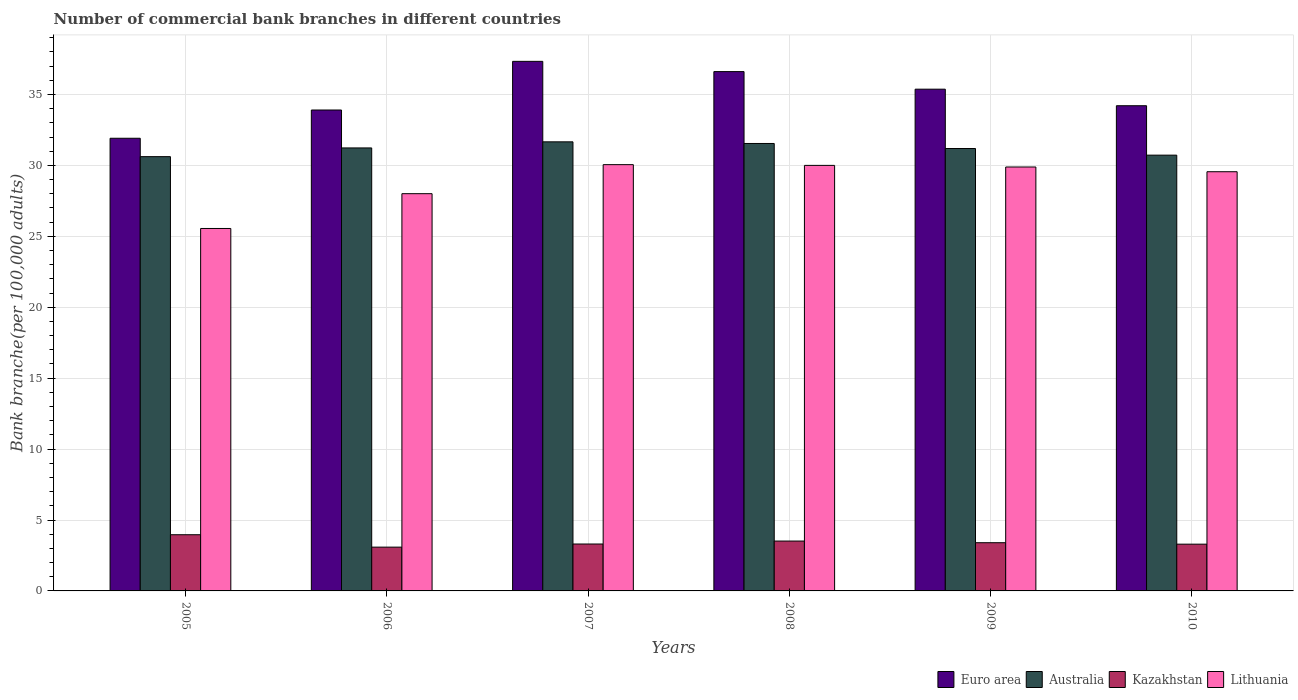How many bars are there on the 6th tick from the left?
Your answer should be very brief. 4. How many bars are there on the 4th tick from the right?
Your answer should be compact. 4. What is the number of commercial bank branches in Kazakhstan in 2008?
Provide a succinct answer. 3.52. Across all years, what is the maximum number of commercial bank branches in Euro area?
Give a very brief answer. 37.34. Across all years, what is the minimum number of commercial bank branches in Australia?
Your answer should be very brief. 30.62. What is the total number of commercial bank branches in Kazakhstan in the graph?
Ensure brevity in your answer.  20.57. What is the difference between the number of commercial bank branches in Australia in 2006 and that in 2008?
Keep it short and to the point. -0.31. What is the difference between the number of commercial bank branches in Lithuania in 2010 and the number of commercial bank branches in Kazakhstan in 2009?
Your answer should be compact. 26.16. What is the average number of commercial bank branches in Lithuania per year?
Offer a very short reply. 28.84. In the year 2008, what is the difference between the number of commercial bank branches in Australia and number of commercial bank branches in Kazakhstan?
Your answer should be very brief. 28.03. What is the ratio of the number of commercial bank branches in Australia in 2005 to that in 2009?
Your response must be concise. 0.98. Is the number of commercial bank branches in Euro area in 2008 less than that in 2010?
Your answer should be compact. No. Is the difference between the number of commercial bank branches in Australia in 2008 and 2009 greater than the difference between the number of commercial bank branches in Kazakhstan in 2008 and 2009?
Your answer should be compact. Yes. What is the difference between the highest and the second highest number of commercial bank branches in Euro area?
Offer a terse response. 0.72. What is the difference between the highest and the lowest number of commercial bank branches in Australia?
Your answer should be very brief. 1.04. In how many years, is the number of commercial bank branches in Australia greater than the average number of commercial bank branches in Australia taken over all years?
Provide a succinct answer. 4. What does the 4th bar from the left in 2009 represents?
Keep it short and to the point. Lithuania. What does the 2nd bar from the right in 2006 represents?
Provide a succinct answer. Kazakhstan. Is it the case that in every year, the sum of the number of commercial bank branches in Kazakhstan and number of commercial bank branches in Euro area is greater than the number of commercial bank branches in Australia?
Your answer should be compact. Yes. How many bars are there?
Your answer should be compact. 24. Are all the bars in the graph horizontal?
Give a very brief answer. No. How many years are there in the graph?
Make the answer very short. 6. Does the graph contain any zero values?
Offer a very short reply. No. Where does the legend appear in the graph?
Your answer should be compact. Bottom right. How many legend labels are there?
Make the answer very short. 4. How are the legend labels stacked?
Offer a terse response. Horizontal. What is the title of the graph?
Your answer should be compact. Number of commercial bank branches in different countries. Does "East Asia (developing only)" appear as one of the legend labels in the graph?
Your answer should be compact. No. What is the label or title of the X-axis?
Your response must be concise. Years. What is the label or title of the Y-axis?
Keep it short and to the point. Bank branche(per 100,0 adults). What is the Bank branche(per 100,000 adults) in Euro area in 2005?
Provide a succinct answer. 31.92. What is the Bank branche(per 100,000 adults) of Australia in 2005?
Provide a succinct answer. 30.62. What is the Bank branche(per 100,000 adults) in Kazakhstan in 2005?
Make the answer very short. 3.96. What is the Bank branche(per 100,000 adults) in Lithuania in 2005?
Your answer should be very brief. 25.55. What is the Bank branche(per 100,000 adults) of Euro area in 2006?
Offer a very short reply. 33.91. What is the Bank branche(per 100,000 adults) in Australia in 2006?
Keep it short and to the point. 31.23. What is the Bank branche(per 100,000 adults) in Kazakhstan in 2006?
Your answer should be compact. 3.09. What is the Bank branche(per 100,000 adults) of Lithuania in 2006?
Your response must be concise. 28.01. What is the Bank branche(per 100,000 adults) in Euro area in 2007?
Offer a very short reply. 37.34. What is the Bank branche(per 100,000 adults) of Australia in 2007?
Ensure brevity in your answer.  31.66. What is the Bank branche(per 100,000 adults) in Kazakhstan in 2007?
Keep it short and to the point. 3.31. What is the Bank branche(per 100,000 adults) in Lithuania in 2007?
Provide a succinct answer. 30.05. What is the Bank branche(per 100,000 adults) of Euro area in 2008?
Make the answer very short. 36.62. What is the Bank branche(per 100,000 adults) in Australia in 2008?
Give a very brief answer. 31.55. What is the Bank branche(per 100,000 adults) of Kazakhstan in 2008?
Keep it short and to the point. 3.52. What is the Bank branche(per 100,000 adults) in Lithuania in 2008?
Ensure brevity in your answer.  30. What is the Bank branche(per 100,000 adults) in Euro area in 2009?
Ensure brevity in your answer.  35.38. What is the Bank branche(per 100,000 adults) in Australia in 2009?
Make the answer very short. 31.19. What is the Bank branche(per 100,000 adults) in Kazakhstan in 2009?
Give a very brief answer. 3.4. What is the Bank branche(per 100,000 adults) in Lithuania in 2009?
Your answer should be compact. 29.89. What is the Bank branche(per 100,000 adults) of Euro area in 2010?
Offer a terse response. 34.21. What is the Bank branche(per 100,000 adults) in Australia in 2010?
Your answer should be compact. 30.73. What is the Bank branche(per 100,000 adults) of Kazakhstan in 2010?
Your answer should be compact. 3.3. What is the Bank branche(per 100,000 adults) in Lithuania in 2010?
Offer a very short reply. 29.56. Across all years, what is the maximum Bank branche(per 100,000 adults) in Euro area?
Your answer should be very brief. 37.34. Across all years, what is the maximum Bank branche(per 100,000 adults) of Australia?
Ensure brevity in your answer.  31.66. Across all years, what is the maximum Bank branche(per 100,000 adults) in Kazakhstan?
Provide a short and direct response. 3.96. Across all years, what is the maximum Bank branche(per 100,000 adults) in Lithuania?
Your answer should be compact. 30.05. Across all years, what is the minimum Bank branche(per 100,000 adults) in Euro area?
Your answer should be compact. 31.92. Across all years, what is the minimum Bank branche(per 100,000 adults) of Australia?
Your answer should be compact. 30.62. Across all years, what is the minimum Bank branche(per 100,000 adults) in Kazakhstan?
Offer a terse response. 3.09. Across all years, what is the minimum Bank branche(per 100,000 adults) in Lithuania?
Provide a succinct answer. 25.55. What is the total Bank branche(per 100,000 adults) of Euro area in the graph?
Offer a terse response. 209.36. What is the total Bank branche(per 100,000 adults) of Australia in the graph?
Make the answer very short. 186.98. What is the total Bank branche(per 100,000 adults) in Kazakhstan in the graph?
Provide a succinct answer. 20.57. What is the total Bank branche(per 100,000 adults) of Lithuania in the graph?
Provide a succinct answer. 173.07. What is the difference between the Bank branche(per 100,000 adults) in Euro area in 2005 and that in 2006?
Provide a short and direct response. -1.99. What is the difference between the Bank branche(per 100,000 adults) in Australia in 2005 and that in 2006?
Your answer should be compact. -0.61. What is the difference between the Bank branche(per 100,000 adults) in Kazakhstan in 2005 and that in 2006?
Keep it short and to the point. 0.87. What is the difference between the Bank branche(per 100,000 adults) in Lithuania in 2005 and that in 2006?
Provide a short and direct response. -2.45. What is the difference between the Bank branche(per 100,000 adults) of Euro area in 2005 and that in 2007?
Give a very brief answer. -5.42. What is the difference between the Bank branche(per 100,000 adults) in Australia in 2005 and that in 2007?
Provide a succinct answer. -1.04. What is the difference between the Bank branche(per 100,000 adults) of Kazakhstan in 2005 and that in 2007?
Give a very brief answer. 0.65. What is the difference between the Bank branche(per 100,000 adults) in Lithuania in 2005 and that in 2007?
Your response must be concise. -4.5. What is the difference between the Bank branche(per 100,000 adults) in Euro area in 2005 and that in 2008?
Offer a very short reply. -4.7. What is the difference between the Bank branche(per 100,000 adults) in Australia in 2005 and that in 2008?
Your answer should be compact. -0.93. What is the difference between the Bank branche(per 100,000 adults) of Kazakhstan in 2005 and that in 2008?
Ensure brevity in your answer.  0.45. What is the difference between the Bank branche(per 100,000 adults) in Lithuania in 2005 and that in 2008?
Your answer should be compact. -4.45. What is the difference between the Bank branche(per 100,000 adults) in Euro area in 2005 and that in 2009?
Your response must be concise. -3.46. What is the difference between the Bank branche(per 100,000 adults) of Australia in 2005 and that in 2009?
Your answer should be compact. -0.57. What is the difference between the Bank branche(per 100,000 adults) of Kazakhstan in 2005 and that in 2009?
Keep it short and to the point. 0.56. What is the difference between the Bank branche(per 100,000 adults) of Lithuania in 2005 and that in 2009?
Your response must be concise. -4.34. What is the difference between the Bank branche(per 100,000 adults) of Euro area in 2005 and that in 2010?
Your answer should be very brief. -2.29. What is the difference between the Bank branche(per 100,000 adults) of Australia in 2005 and that in 2010?
Offer a very short reply. -0.11. What is the difference between the Bank branche(per 100,000 adults) in Kazakhstan in 2005 and that in 2010?
Your response must be concise. 0.67. What is the difference between the Bank branche(per 100,000 adults) of Lithuania in 2005 and that in 2010?
Make the answer very short. -4. What is the difference between the Bank branche(per 100,000 adults) of Euro area in 2006 and that in 2007?
Keep it short and to the point. -3.43. What is the difference between the Bank branche(per 100,000 adults) in Australia in 2006 and that in 2007?
Give a very brief answer. -0.43. What is the difference between the Bank branche(per 100,000 adults) of Kazakhstan in 2006 and that in 2007?
Provide a succinct answer. -0.22. What is the difference between the Bank branche(per 100,000 adults) of Lithuania in 2006 and that in 2007?
Give a very brief answer. -2.05. What is the difference between the Bank branche(per 100,000 adults) of Euro area in 2006 and that in 2008?
Offer a very short reply. -2.71. What is the difference between the Bank branche(per 100,000 adults) in Australia in 2006 and that in 2008?
Give a very brief answer. -0.31. What is the difference between the Bank branche(per 100,000 adults) in Kazakhstan in 2006 and that in 2008?
Provide a succinct answer. -0.43. What is the difference between the Bank branche(per 100,000 adults) of Lithuania in 2006 and that in 2008?
Give a very brief answer. -2. What is the difference between the Bank branche(per 100,000 adults) in Euro area in 2006 and that in 2009?
Your response must be concise. -1.47. What is the difference between the Bank branche(per 100,000 adults) of Australia in 2006 and that in 2009?
Give a very brief answer. 0.04. What is the difference between the Bank branche(per 100,000 adults) in Kazakhstan in 2006 and that in 2009?
Your answer should be compact. -0.31. What is the difference between the Bank branche(per 100,000 adults) in Lithuania in 2006 and that in 2009?
Your answer should be compact. -1.88. What is the difference between the Bank branche(per 100,000 adults) of Euro area in 2006 and that in 2010?
Keep it short and to the point. -0.3. What is the difference between the Bank branche(per 100,000 adults) of Australia in 2006 and that in 2010?
Offer a very short reply. 0.51. What is the difference between the Bank branche(per 100,000 adults) in Kazakhstan in 2006 and that in 2010?
Your answer should be compact. -0.21. What is the difference between the Bank branche(per 100,000 adults) of Lithuania in 2006 and that in 2010?
Your answer should be compact. -1.55. What is the difference between the Bank branche(per 100,000 adults) of Euro area in 2007 and that in 2008?
Give a very brief answer. 0.72. What is the difference between the Bank branche(per 100,000 adults) in Australia in 2007 and that in 2008?
Your answer should be very brief. 0.12. What is the difference between the Bank branche(per 100,000 adults) of Kazakhstan in 2007 and that in 2008?
Your answer should be compact. -0.21. What is the difference between the Bank branche(per 100,000 adults) of Lithuania in 2007 and that in 2008?
Provide a succinct answer. 0.05. What is the difference between the Bank branche(per 100,000 adults) in Euro area in 2007 and that in 2009?
Offer a terse response. 1.96. What is the difference between the Bank branche(per 100,000 adults) of Australia in 2007 and that in 2009?
Your answer should be compact. 0.47. What is the difference between the Bank branche(per 100,000 adults) in Kazakhstan in 2007 and that in 2009?
Keep it short and to the point. -0.09. What is the difference between the Bank branche(per 100,000 adults) of Lithuania in 2007 and that in 2009?
Offer a very short reply. 0.16. What is the difference between the Bank branche(per 100,000 adults) of Euro area in 2007 and that in 2010?
Provide a succinct answer. 3.13. What is the difference between the Bank branche(per 100,000 adults) in Australia in 2007 and that in 2010?
Keep it short and to the point. 0.94. What is the difference between the Bank branche(per 100,000 adults) of Kazakhstan in 2007 and that in 2010?
Your answer should be compact. 0.01. What is the difference between the Bank branche(per 100,000 adults) in Lithuania in 2007 and that in 2010?
Provide a short and direct response. 0.5. What is the difference between the Bank branche(per 100,000 adults) in Euro area in 2008 and that in 2009?
Make the answer very short. 1.24. What is the difference between the Bank branche(per 100,000 adults) of Australia in 2008 and that in 2009?
Keep it short and to the point. 0.35. What is the difference between the Bank branche(per 100,000 adults) of Kazakhstan in 2008 and that in 2009?
Your response must be concise. 0.12. What is the difference between the Bank branche(per 100,000 adults) in Lithuania in 2008 and that in 2009?
Give a very brief answer. 0.11. What is the difference between the Bank branche(per 100,000 adults) in Euro area in 2008 and that in 2010?
Offer a very short reply. 2.41. What is the difference between the Bank branche(per 100,000 adults) in Australia in 2008 and that in 2010?
Provide a short and direct response. 0.82. What is the difference between the Bank branche(per 100,000 adults) in Kazakhstan in 2008 and that in 2010?
Offer a terse response. 0.22. What is the difference between the Bank branche(per 100,000 adults) of Lithuania in 2008 and that in 2010?
Keep it short and to the point. 0.45. What is the difference between the Bank branche(per 100,000 adults) in Euro area in 2009 and that in 2010?
Provide a short and direct response. 1.17. What is the difference between the Bank branche(per 100,000 adults) in Australia in 2009 and that in 2010?
Make the answer very short. 0.47. What is the difference between the Bank branche(per 100,000 adults) in Kazakhstan in 2009 and that in 2010?
Offer a terse response. 0.1. What is the difference between the Bank branche(per 100,000 adults) in Lithuania in 2009 and that in 2010?
Your response must be concise. 0.33. What is the difference between the Bank branche(per 100,000 adults) in Euro area in 2005 and the Bank branche(per 100,000 adults) in Australia in 2006?
Your answer should be compact. 0.68. What is the difference between the Bank branche(per 100,000 adults) in Euro area in 2005 and the Bank branche(per 100,000 adults) in Kazakhstan in 2006?
Make the answer very short. 28.83. What is the difference between the Bank branche(per 100,000 adults) in Euro area in 2005 and the Bank branche(per 100,000 adults) in Lithuania in 2006?
Your answer should be compact. 3.91. What is the difference between the Bank branche(per 100,000 adults) of Australia in 2005 and the Bank branche(per 100,000 adults) of Kazakhstan in 2006?
Ensure brevity in your answer.  27.53. What is the difference between the Bank branche(per 100,000 adults) in Australia in 2005 and the Bank branche(per 100,000 adults) in Lithuania in 2006?
Your answer should be compact. 2.61. What is the difference between the Bank branche(per 100,000 adults) of Kazakhstan in 2005 and the Bank branche(per 100,000 adults) of Lithuania in 2006?
Your answer should be very brief. -24.05. What is the difference between the Bank branche(per 100,000 adults) of Euro area in 2005 and the Bank branche(per 100,000 adults) of Australia in 2007?
Your answer should be compact. 0.25. What is the difference between the Bank branche(per 100,000 adults) of Euro area in 2005 and the Bank branche(per 100,000 adults) of Kazakhstan in 2007?
Offer a terse response. 28.61. What is the difference between the Bank branche(per 100,000 adults) of Euro area in 2005 and the Bank branche(per 100,000 adults) of Lithuania in 2007?
Offer a terse response. 1.86. What is the difference between the Bank branche(per 100,000 adults) of Australia in 2005 and the Bank branche(per 100,000 adults) of Kazakhstan in 2007?
Your answer should be compact. 27.31. What is the difference between the Bank branche(per 100,000 adults) of Australia in 2005 and the Bank branche(per 100,000 adults) of Lithuania in 2007?
Keep it short and to the point. 0.56. What is the difference between the Bank branche(per 100,000 adults) in Kazakhstan in 2005 and the Bank branche(per 100,000 adults) in Lithuania in 2007?
Give a very brief answer. -26.09. What is the difference between the Bank branche(per 100,000 adults) of Euro area in 2005 and the Bank branche(per 100,000 adults) of Australia in 2008?
Your answer should be compact. 0.37. What is the difference between the Bank branche(per 100,000 adults) of Euro area in 2005 and the Bank branche(per 100,000 adults) of Kazakhstan in 2008?
Keep it short and to the point. 28.4. What is the difference between the Bank branche(per 100,000 adults) of Euro area in 2005 and the Bank branche(per 100,000 adults) of Lithuania in 2008?
Offer a very short reply. 1.91. What is the difference between the Bank branche(per 100,000 adults) in Australia in 2005 and the Bank branche(per 100,000 adults) in Kazakhstan in 2008?
Provide a succinct answer. 27.1. What is the difference between the Bank branche(per 100,000 adults) of Australia in 2005 and the Bank branche(per 100,000 adults) of Lithuania in 2008?
Provide a short and direct response. 0.62. What is the difference between the Bank branche(per 100,000 adults) in Kazakhstan in 2005 and the Bank branche(per 100,000 adults) in Lithuania in 2008?
Provide a succinct answer. -26.04. What is the difference between the Bank branche(per 100,000 adults) in Euro area in 2005 and the Bank branche(per 100,000 adults) in Australia in 2009?
Make the answer very short. 0.72. What is the difference between the Bank branche(per 100,000 adults) of Euro area in 2005 and the Bank branche(per 100,000 adults) of Kazakhstan in 2009?
Offer a terse response. 28.52. What is the difference between the Bank branche(per 100,000 adults) in Euro area in 2005 and the Bank branche(per 100,000 adults) in Lithuania in 2009?
Provide a succinct answer. 2.03. What is the difference between the Bank branche(per 100,000 adults) of Australia in 2005 and the Bank branche(per 100,000 adults) of Kazakhstan in 2009?
Give a very brief answer. 27.22. What is the difference between the Bank branche(per 100,000 adults) in Australia in 2005 and the Bank branche(per 100,000 adults) in Lithuania in 2009?
Offer a very short reply. 0.73. What is the difference between the Bank branche(per 100,000 adults) in Kazakhstan in 2005 and the Bank branche(per 100,000 adults) in Lithuania in 2009?
Make the answer very short. -25.93. What is the difference between the Bank branche(per 100,000 adults) of Euro area in 2005 and the Bank branche(per 100,000 adults) of Australia in 2010?
Offer a terse response. 1.19. What is the difference between the Bank branche(per 100,000 adults) in Euro area in 2005 and the Bank branche(per 100,000 adults) in Kazakhstan in 2010?
Make the answer very short. 28.62. What is the difference between the Bank branche(per 100,000 adults) of Euro area in 2005 and the Bank branche(per 100,000 adults) of Lithuania in 2010?
Offer a terse response. 2.36. What is the difference between the Bank branche(per 100,000 adults) in Australia in 2005 and the Bank branche(per 100,000 adults) in Kazakhstan in 2010?
Your answer should be compact. 27.32. What is the difference between the Bank branche(per 100,000 adults) in Australia in 2005 and the Bank branche(per 100,000 adults) in Lithuania in 2010?
Your answer should be compact. 1.06. What is the difference between the Bank branche(per 100,000 adults) of Kazakhstan in 2005 and the Bank branche(per 100,000 adults) of Lithuania in 2010?
Your response must be concise. -25.59. What is the difference between the Bank branche(per 100,000 adults) of Euro area in 2006 and the Bank branche(per 100,000 adults) of Australia in 2007?
Provide a succinct answer. 2.24. What is the difference between the Bank branche(per 100,000 adults) of Euro area in 2006 and the Bank branche(per 100,000 adults) of Kazakhstan in 2007?
Provide a succinct answer. 30.6. What is the difference between the Bank branche(per 100,000 adults) in Euro area in 2006 and the Bank branche(per 100,000 adults) in Lithuania in 2007?
Offer a very short reply. 3.85. What is the difference between the Bank branche(per 100,000 adults) in Australia in 2006 and the Bank branche(per 100,000 adults) in Kazakhstan in 2007?
Offer a very short reply. 27.93. What is the difference between the Bank branche(per 100,000 adults) in Australia in 2006 and the Bank branche(per 100,000 adults) in Lithuania in 2007?
Give a very brief answer. 1.18. What is the difference between the Bank branche(per 100,000 adults) of Kazakhstan in 2006 and the Bank branche(per 100,000 adults) of Lithuania in 2007?
Give a very brief answer. -26.97. What is the difference between the Bank branche(per 100,000 adults) in Euro area in 2006 and the Bank branche(per 100,000 adults) in Australia in 2008?
Give a very brief answer. 2.36. What is the difference between the Bank branche(per 100,000 adults) in Euro area in 2006 and the Bank branche(per 100,000 adults) in Kazakhstan in 2008?
Offer a terse response. 30.39. What is the difference between the Bank branche(per 100,000 adults) in Euro area in 2006 and the Bank branche(per 100,000 adults) in Lithuania in 2008?
Your response must be concise. 3.9. What is the difference between the Bank branche(per 100,000 adults) in Australia in 2006 and the Bank branche(per 100,000 adults) in Kazakhstan in 2008?
Keep it short and to the point. 27.72. What is the difference between the Bank branche(per 100,000 adults) in Australia in 2006 and the Bank branche(per 100,000 adults) in Lithuania in 2008?
Ensure brevity in your answer.  1.23. What is the difference between the Bank branche(per 100,000 adults) in Kazakhstan in 2006 and the Bank branche(per 100,000 adults) in Lithuania in 2008?
Your answer should be very brief. -26.92. What is the difference between the Bank branche(per 100,000 adults) in Euro area in 2006 and the Bank branche(per 100,000 adults) in Australia in 2009?
Keep it short and to the point. 2.71. What is the difference between the Bank branche(per 100,000 adults) in Euro area in 2006 and the Bank branche(per 100,000 adults) in Kazakhstan in 2009?
Your answer should be compact. 30.51. What is the difference between the Bank branche(per 100,000 adults) of Euro area in 2006 and the Bank branche(per 100,000 adults) of Lithuania in 2009?
Keep it short and to the point. 4.02. What is the difference between the Bank branche(per 100,000 adults) in Australia in 2006 and the Bank branche(per 100,000 adults) in Kazakhstan in 2009?
Ensure brevity in your answer.  27.83. What is the difference between the Bank branche(per 100,000 adults) in Australia in 2006 and the Bank branche(per 100,000 adults) in Lithuania in 2009?
Make the answer very short. 1.34. What is the difference between the Bank branche(per 100,000 adults) of Kazakhstan in 2006 and the Bank branche(per 100,000 adults) of Lithuania in 2009?
Your answer should be very brief. -26.8. What is the difference between the Bank branche(per 100,000 adults) in Euro area in 2006 and the Bank branche(per 100,000 adults) in Australia in 2010?
Keep it short and to the point. 3.18. What is the difference between the Bank branche(per 100,000 adults) of Euro area in 2006 and the Bank branche(per 100,000 adults) of Kazakhstan in 2010?
Make the answer very short. 30.61. What is the difference between the Bank branche(per 100,000 adults) of Euro area in 2006 and the Bank branche(per 100,000 adults) of Lithuania in 2010?
Offer a terse response. 4.35. What is the difference between the Bank branche(per 100,000 adults) in Australia in 2006 and the Bank branche(per 100,000 adults) in Kazakhstan in 2010?
Provide a succinct answer. 27.94. What is the difference between the Bank branche(per 100,000 adults) of Australia in 2006 and the Bank branche(per 100,000 adults) of Lithuania in 2010?
Your response must be concise. 1.68. What is the difference between the Bank branche(per 100,000 adults) in Kazakhstan in 2006 and the Bank branche(per 100,000 adults) in Lithuania in 2010?
Your response must be concise. -26.47. What is the difference between the Bank branche(per 100,000 adults) of Euro area in 2007 and the Bank branche(per 100,000 adults) of Australia in 2008?
Your answer should be compact. 5.79. What is the difference between the Bank branche(per 100,000 adults) of Euro area in 2007 and the Bank branche(per 100,000 adults) of Kazakhstan in 2008?
Give a very brief answer. 33.82. What is the difference between the Bank branche(per 100,000 adults) in Euro area in 2007 and the Bank branche(per 100,000 adults) in Lithuania in 2008?
Provide a short and direct response. 7.33. What is the difference between the Bank branche(per 100,000 adults) of Australia in 2007 and the Bank branche(per 100,000 adults) of Kazakhstan in 2008?
Offer a terse response. 28.15. What is the difference between the Bank branche(per 100,000 adults) of Australia in 2007 and the Bank branche(per 100,000 adults) of Lithuania in 2008?
Your response must be concise. 1.66. What is the difference between the Bank branche(per 100,000 adults) of Kazakhstan in 2007 and the Bank branche(per 100,000 adults) of Lithuania in 2008?
Your answer should be very brief. -26.7. What is the difference between the Bank branche(per 100,000 adults) in Euro area in 2007 and the Bank branche(per 100,000 adults) in Australia in 2009?
Provide a short and direct response. 6.15. What is the difference between the Bank branche(per 100,000 adults) in Euro area in 2007 and the Bank branche(per 100,000 adults) in Kazakhstan in 2009?
Ensure brevity in your answer.  33.94. What is the difference between the Bank branche(per 100,000 adults) in Euro area in 2007 and the Bank branche(per 100,000 adults) in Lithuania in 2009?
Offer a very short reply. 7.45. What is the difference between the Bank branche(per 100,000 adults) in Australia in 2007 and the Bank branche(per 100,000 adults) in Kazakhstan in 2009?
Your answer should be compact. 28.26. What is the difference between the Bank branche(per 100,000 adults) in Australia in 2007 and the Bank branche(per 100,000 adults) in Lithuania in 2009?
Ensure brevity in your answer.  1.77. What is the difference between the Bank branche(per 100,000 adults) in Kazakhstan in 2007 and the Bank branche(per 100,000 adults) in Lithuania in 2009?
Your response must be concise. -26.58. What is the difference between the Bank branche(per 100,000 adults) of Euro area in 2007 and the Bank branche(per 100,000 adults) of Australia in 2010?
Your response must be concise. 6.61. What is the difference between the Bank branche(per 100,000 adults) of Euro area in 2007 and the Bank branche(per 100,000 adults) of Kazakhstan in 2010?
Make the answer very short. 34.04. What is the difference between the Bank branche(per 100,000 adults) of Euro area in 2007 and the Bank branche(per 100,000 adults) of Lithuania in 2010?
Your response must be concise. 7.78. What is the difference between the Bank branche(per 100,000 adults) of Australia in 2007 and the Bank branche(per 100,000 adults) of Kazakhstan in 2010?
Provide a succinct answer. 28.37. What is the difference between the Bank branche(per 100,000 adults) of Australia in 2007 and the Bank branche(per 100,000 adults) of Lithuania in 2010?
Offer a very short reply. 2.11. What is the difference between the Bank branche(per 100,000 adults) in Kazakhstan in 2007 and the Bank branche(per 100,000 adults) in Lithuania in 2010?
Your answer should be compact. -26.25. What is the difference between the Bank branche(per 100,000 adults) in Euro area in 2008 and the Bank branche(per 100,000 adults) in Australia in 2009?
Offer a very short reply. 5.42. What is the difference between the Bank branche(per 100,000 adults) in Euro area in 2008 and the Bank branche(per 100,000 adults) in Kazakhstan in 2009?
Your answer should be compact. 33.22. What is the difference between the Bank branche(per 100,000 adults) in Euro area in 2008 and the Bank branche(per 100,000 adults) in Lithuania in 2009?
Give a very brief answer. 6.73. What is the difference between the Bank branche(per 100,000 adults) of Australia in 2008 and the Bank branche(per 100,000 adults) of Kazakhstan in 2009?
Provide a short and direct response. 28.15. What is the difference between the Bank branche(per 100,000 adults) in Australia in 2008 and the Bank branche(per 100,000 adults) in Lithuania in 2009?
Your answer should be very brief. 1.66. What is the difference between the Bank branche(per 100,000 adults) of Kazakhstan in 2008 and the Bank branche(per 100,000 adults) of Lithuania in 2009?
Provide a short and direct response. -26.37. What is the difference between the Bank branche(per 100,000 adults) in Euro area in 2008 and the Bank branche(per 100,000 adults) in Australia in 2010?
Ensure brevity in your answer.  5.89. What is the difference between the Bank branche(per 100,000 adults) of Euro area in 2008 and the Bank branche(per 100,000 adults) of Kazakhstan in 2010?
Your response must be concise. 33.32. What is the difference between the Bank branche(per 100,000 adults) in Euro area in 2008 and the Bank branche(per 100,000 adults) in Lithuania in 2010?
Ensure brevity in your answer.  7.06. What is the difference between the Bank branche(per 100,000 adults) in Australia in 2008 and the Bank branche(per 100,000 adults) in Kazakhstan in 2010?
Ensure brevity in your answer.  28.25. What is the difference between the Bank branche(per 100,000 adults) in Australia in 2008 and the Bank branche(per 100,000 adults) in Lithuania in 2010?
Your response must be concise. 1.99. What is the difference between the Bank branche(per 100,000 adults) in Kazakhstan in 2008 and the Bank branche(per 100,000 adults) in Lithuania in 2010?
Ensure brevity in your answer.  -26.04. What is the difference between the Bank branche(per 100,000 adults) of Euro area in 2009 and the Bank branche(per 100,000 adults) of Australia in 2010?
Give a very brief answer. 4.65. What is the difference between the Bank branche(per 100,000 adults) of Euro area in 2009 and the Bank branche(per 100,000 adults) of Kazakhstan in 2010?
Keep it short and to the point. 32.08. What is the difference between the Bank branche(per 100,000 adults) of Euro area in 2009 and the Bank branche(per 100,000 adults) of Lithuania in 2010?
Your answer should be compact. 5.82. What is the difference between the Bank branche(per 100,000 adults) in Australia in 2009 and the Bank branche(per 100,000 adults) in Kazakhstan in 2010?
Offer a very short reply. 27.9. What is the difference between the Bank branche(per 100,000 adults) of Australia in 2009 and the Bank branche(per 100,000 adults) of Lithuania in 2010?
Give a very brief answer. 1.64. What is the difference between the Bank branche(per 100,000 adults) of Kazakhstan in 2009 and the Bank branche(per 100,000 adults) of Lithuania in 2010?
Offer a very short reply. -26.16. What is the average Bank branche(per 100,000 adults) of Euro area per year?
Ensure brevity in your answer.  34.89. What is the average Bank branche(per 100,000 adults) of Australia per year?
Give a very brief answer. 31.16. What is the average Bank branche(per 100,000 adults) in Kazakhstan per year?
Ensure brevity in your answer.  3.43. What is the average Bank branche(per 100,000 adults) in Lithuania per year?
Ensure brevity in your answer.  28.84. In the year 2005, what is the difference between the Bank branche(per 100,000 adults) in Euro area and Bank branche(per 100,000 adults) in Australia?
Ensure brevity in your answer.  1.3. In the year 2005, what is the difference between the Bank branche(per 100,000 adults) of Euro area and Bank branche(per 100,000 adults) of Kazakhstan?
Provide a short and direct response. 27.95. In the year 2005, what is the difference between the Bank branche(per 100,000 adults) in Euro area and Bank branche(per 100,000 adults) in Lithuania?
Offer a terse response. 6.36. In the year 2005, what is the difference between the Bank branche(per 100,000 adults) of Australia and Bank branche(per 100,000 adults) of Kazakhstan?
Provide a succinct answer. 26.66. In the year 2005, what is the difference between the Bank branche(per 100,000 adults) of Australia and Bank branche(per 100,000 adults) of Lithuania?
Ensure brevity in your answer.  5.06. In the year 2005, what is the difference between the Bank branche(per 100,000 adults) of Kazakhstan and Bank branche(per 100,000 adults) of Lithuania?
Your response must be concise. -21.59. In the year 2006, what is the difference between the Bank branche(per 100,000 adults) in Euro area and Bank branche(per 100,000 adults) in Australia?
Keep it short and to the point. 2.67. In the year 2006, what is the difference between the Bank branche(per 100,000 adults) in Euro area and Bank branche(per 100,000 adults) in Kazakhstan?
Keep it short and to the point. 30.82. In the year 2006, what is the difference between the Bank branche(per 100,000 adults) of Euro area and Bank branche(per 100,000 adults) of Lithuania?
Your answer should be very brief. 5.9. In the year 2006, what is the difference between the Bank branche(per 100,000 adults) of Australia and Bank branche(per 100,000 adults) of Kazakhstan?
Your answer should be very brief. 28.15. In the year 2006, what is the difference between the Bank branche(per 100,000 adults) of Australia and Bank branche(per 100,000 adults) of Lithuania?
Offer a very short reply. 3.23. In the year 2006, what is the difference between the Bank branche(per 100,000 adults) in Kazakhstan and Bank branche(per 100,000 adults) in Lithuania?
Make the answer very short. -24.92. In the year 2007, what is the difference between the Bank branche(per 100,000 adults) of Euro area and Bank branche(per 100,000 adults) of Australia?
Ensure brevity in your answer.  5.67. In the year 2007, what is the difference between the Bank branche(per 100,000 adults) in Euro area and Bank branche(per 100,000 adults) in Kazakhstan?
Offer a terse response. 34.03. In the year 2007, what is the difference between the Bank branche(per 100,000 adults) of Euro area and Bank branche(per 100,000 adults) of Lithuania?
Offer a terse response. 7.28. In the year 2007, what is the difference between the Bank branche(per 100,000 adults) in Australia and Bank branche(per 100,000 adults) in Kazakhstan?
Offer a terse response. 28.36. In the year 2007, what is the difference between the Bank branche(per 100,000 adults) in Australia and Bank branche(per 100,000 adults) in Lithuania?
Provide a succinct answer. 1.61. In the year 2007, what is the difference between the Bank branche(per 100,000 adults) in Kazakhstan and Bank branche(per 100,000 adults) in Lithuania?
Your answer should be compact. -26.75. In the year 2008, what is the difference between the Bank branche(per 100,000 adults) in Euro area and Bank branche(per 100,000 adults) in Australia?
Your response must be concise. 5.07. In the year 2008, what is the difference between the Bank branche(per 100,000 adults) in Euro area and Bank branche(per 100,000 adults) in Kazakhstan?
Provide a short and direct response. 33.1. In the year 2008, what is the difference between the Bank branche(per 100,000 adults) of Euro area and Bank branche(per 100,000 adults) of Lithuania?
Ensure brevity in your answer.  6.61. In the year 2008, what is the difference between the Bank branche(per 100,000 adults) in Australia and Bank branche(per 100,000 adults) in Kazakhstan?
Give a very brief answer. 28.03. In the year 2008, what is the difference between the Bank branche(per 100,000 adults) in Australia and Bank branche(per 100,000 adults) in Lithuania?
Give a very brief answer. 1.54. In the year 2008, what is the difference between the Bank branche(per 100,000 adults) in Kazakhstan and Bank branche(per 100,000 adults) in Lithuania?
Provide a succinct answer. -26.49. In the year 2009, what is the difference between the Bank branche(per 100,000 adults) in Euro area and Bank branche(per 100,000 adults) in Australia?
Offer a terse response. 4.18. In the year 2009, what is the difference between the Bank branche(per 100,000 adults) of Euro area and Bank branche(per 100,000 adults) of Kazakhstan?
Provide a succinct answer. 31.98. In the year 2009, what is the difference between the Bank branche(per 100,000 adults) of Euro area and Bank branche(per 100,000 adults) of Lithuania?
Your answer should be compact. 5.49. In the year 2009, what is the difference between the Bank branche(per 100,000 adults) in Australia and Bank branche(per 100,000 adults) in Kazakhstan?
Your answer should be very brief. 27.79. In the year 2009, what is the difference between the Bank branche(per 100,000 adults) in Australia and Bank branche(per 100,000 adults) in Lithuania?
Provide a succinct answer. 1.3. In the year 2009, what is the difference between the Bank branche(per 100,000 adults) in Kazakhstan and Bank branche(per 100,000 adults) in Lithuania?
Offer a terse response. -26.49. In the year 2010, what is the difference between the Bank branche(per 100,000 adults) of Euro area and Bank branche(per 100,000 adults) of Australia?
Ensure brevity in your answer.  3.48. In the year 2010, what is the difference between the Bank branche(per 100,000 adults) of Euro area and Bank branche(per 100,000 adults) of Kazakhstan?
Keep it short and to the point. 30.91. In the year 2010, what is the difference between the Bank branche(per 100,000 adults) of Euro area and Bank branche(per 100,000 adults) of Lithuania?
Keep it short and to the point. 4.65. In the year 2010, what is the difference between the Bank branche(per 100,000 adults) of Australia and Bank branche(per 100,000 adults) of Kazakhstan?
Provide a short and direct response. 27.43. In the year 2010, what is the difference between the Bank branche(per 100,000 adults) in Australia and Bank branche(per 100,000 adults) in Lithuania?
Your response must be concise. 1.17. In the year 2010, what is the difference between the Bank branche(per 100,000 adults) in Kazakhstan and Bank branche(per 100,000 adults) in Lithuania?
Ensure brevity in your answer.  -26.26. What is the ratio of the Bank branche(per 100,000 adults) in Euro area in 2005 to that in 2006?
Your response must be concise. 0.94. What is the ratio of the Bank branche(per 100,000 adults) in Australia in 2005 to that in 2006?
Provide a short and direct response. 0.98. What is the ratio of the Bank branche(per 100,000 adults) of Kazakhstan in 2005 to that in 2006?
Make the answer very short. 1.28. What is the ratio of the Bank branche(per 100,000 adults) of Lithuania in 2005 to that in 2006?
Your answer should be compact. 0.91. What is the ratio of the Bank branche(per 100,000 adults) of Euro area in 2005 to that in 2007?
Give a very brief answer. 0.85. What is the ratio of the Bank branche(per 100,000 adults) in Australia in 2005 to that in 2007?
Provide a short and direct response. 0.97. What is the ratio of the Bank branche(per 100,000 adults) of Kazakhstan in 2005 to that in 2007?
Make the answer very short. 1.2. What is the ratio of the Bank branche(per 100,000 adults) of Lithuania in 2005 to that in 2007?
Ensure brevity in your answer.  0.85. What is the ratio of the Bank branche(per 100,000 adults) in Euro area in 2005 to that in 2008?
Your answer should be compact. 0.87. What is the ratio of the Bank branche(per 100,000 adults) of Australia in 2005 to that in 2008?
Offer a very short reply. 0.97. What is the ratio of the Bank branche(per 100,000 adults) of Kazakhstan in 2005 to that in 2008?
Your answer should be compact. 1.13. What is the ratio of the Bank branche(per 100,000 adults) of Lithuania in 2005 to that in 2008?
Your answer should be compact. 0.85. What is the ratio of the Bank branche(per 100,000 adults) in Euro area in 2005 to that in 2009?
Your answer should be compact. 0.9. What is the ratio of the Bank branche(per 100,000 adults) of Australia in 2005 to that in 2009?
Keep it short and to the point. 0.98. What is the ratio of the Bank branche(per 100,000 adults) of Kazakhstan in 2005 to that in 2009?
Your answer should be very brief. 1.17. What is the ratio of the Bank branche(per 100,000 adults) in Lithuania in 2005 to that in 2009?
Give a very brief answer. 0.85. What is the ratio of the Bank branche(per 100,000 adults) of Euro area in 2005 to that in 2010?
Keep it short and to the point. 0.93. What is the ratio of the Bank branche(per 100,000 adults) of Kazakhstan in 2005 to that in 2010?
Make the answer very short. 1.2. What is the ratio of the Bank branche(per 100,000 adults) in Lithuania in 2005 to that in 2010?
Offer a very short reply. 0.86. What is the ratio of the Bank branche(per 100,000 adults) of Euro area in 2006 to that in 2007?
Give a very brief answer. 0.91. What is the ratio of the Bank branche(per 100,000 adults) of Australia in 2006 to that in 2007?
Your response must be concise. 0.99. What is the ratio of the Bank branche(per 100,000 adults) in Kazakhstan in 2006 to that in 2007?
Make the answer very short. 0.93. What is the ratio of the Bank branche(per 100,000 adults) of Lithuania in 2006 to that in 2007?
Provide a short and direct response. 0.93. What is the ratio of the Bank branche(per 100,000 adults) of Euro area in 2006 to that in 2008?
Ensure brevity in your answer.  0.93. What is the ratio of the Bank branche(per 100,000 adults) of Kazakhstan in 2006 to that in 2008?
Offer a very short reply. 0.88. What is the ratio of the Bank branche(per 100,000 adults) in Lithuania in 2006 to that in 2008?
Provide a succinct answer. 0.93. What is the ratio of the Bank branche(per 100,000 adults) of Euro area in 2006 to that in 2009?
Make the answer very short. 0.96. What is the ratio of the Bank branche(per 100,000 adults) of Kazakhstan in 2006 to that in 2009?
Your response must be concise. 0.91. What is the ratio of the Bank branche(per 100,000 adults) in Lithuania in 2006 to that in 2009?
Your answer should be compact. 0.94. What is the ratio of the Bank branche(per 100,000 adults) in Euro area in 2006 to that in 2010?
Your answer should be very brief. 0.99. What is the ratio of the Bank branche(per 100,000 adults) of Australia in 2006 to that in 2010?
Offer a terse response. 1.02. What is the ratio of the Bank branche(per 100,000 adults) of Kazakhstan in 2006 to that in 2010?
Ensure brevity in your answer.  0.94. What is the ratio of the Bank branche(per 100,000 adults) in Lithuania in 2006 to that in 2010?
Your response must be concise. 0.95. What is the ratio of the Bank branche(per 100,000 adults) of Euro area in 2007 to that in 2008?
Provide a short and direct response. 1.02. What is the ratio of the Bank branche(per 100,000 adults) in Australia in 2007 to that in 2008?
Ensure brevity in your answer.  1. What is the ratio of the Bank branche(per 100,000 adults) in Kazakhstan in 2007 to that in 2008?
Provide a short and direct response. 0.94. What is the ratio of the Bank branche(per 100,000 adults) of Lithuania in 2007 to that in 2008?
Ensure brevity in your answer.  1. What is the ratio of the Bank branche(per 100,000 adults) in Euro area in 2007 to that in 2009?
Ensure brevity in your answer.  1.06. What is the ratio of the Bank branche(per 100,000 adults) in Australia in 2007 to that in 2009?
Your response must be concise. 1.02. What is the ratio of the Bank branche(per 100,000 adults) in Kazakhstan in 2007 to that in 2009?
Your answer should be compact. 0.97. What is the ratio of the Bank branche(per 100,000 adults) of Lithuania in 2007 to that in 2009?
Ensure brevity in your answer.  1.01. What is the ratio of the Bank branche(per 100,000 adults) of Euro area in 2007 to that in 2010?
Give a very brief answer. 1.09. What is the ratio of the Bank branche(per 100,000 adults) of Australia in 2007 to that in 2010?
Offer a very short reply. 1.03. What is the ratio of the Bank branche(per 100,000 adults) in Lithuania in 2007 to that in 2010?
Your answer should be very brief. 1.02. What is the ratio of the Bank branche(per 100,000 adults) in Euro area in 2008 to that in 2009?
Your answer should be very brief. 1.04. What is the ratio of the Bank branche(per 100,000 adults) in Australia in 2008 to that in 2009?
Your answer should be compact. 1.01. What is the ratio of the Bank branche(per 100,000 adults) of Kazakhstan in 2008 to that in 2009?
Provide a succinct answer. 1.03. What is the ratio of the Bank branche(per 100,000 adults) of Lithuania in 2008 to that in 2009?
Offer a terse response. 1. What is the ratio of the Bank branche(per 100,000 adults) in Euro area in 2008 to that in 2010?
Your response must be concise. 1.07. What is the ratio of the Bank branche(per 100,000 adults) in Australia in 2008 to that in 2010?
Ensure brevity in your answer.  1.03. What is the ratio of the Bank branche(per 100,000 adults) in Kazakhstan in 2008 to that in 2010?
Keep it short and to the point. 1.07. What is the ratio of the Bank branche(per 100,000 adults) of Lithuania in 2008 to that in 2010?
Your response must be concise. 1.02. What is the ratio of the Bank branche(per 100,000 adults) in Euro area in 2009 to that in 2010?
Offer a very short reply. 1.03. What is the ratio of the Bank branche(per 100,000 adults) of Australia in 2009 to that in 2010?
Give a very brief answer. 1.02. What is the ratio of the Bank branche(per 100,000 adults) in Kazakhstan in 2009 to that in 2010?
Offer a very short reply. 1.03. What is the ratio of the Bank branche(per 100,000 adults) in Lithuania in 2009 to that in 2010?
Offer a very short reply. 1.01. What is the difference between the highest and the second highest Bank branche(per 100,000 adults) of Euro area?
Your answer should be compact. 0.72. What is the difference between the highest and the second highest Bank branche(per 100,000 adults) in Australia?
Keep it short and to the point. 0.12. What is the difference between the highest and the second highest Bank branche(per 100,000 adults) of Kazakhstan?
Make the answer very short. 0.45. What is the difference between the highest and the second highest Bank branche(per 100,000 adults) of Lithuania?
Provide a short and direct response. 0.05. What is the difference between the highest and the lowest Bank branche(per 100,000 adults) in Euro area?
Provide a short and direct response. 5.42. What is the difference between the highest and the lowest Bank branche(per 100,000 adults) in Australia?
Make the answer very short. 1.04. What is the difference between the highest and the lowest Bank branche(per 100,000 adults) in Kazakhstan?
Your answer should be very brief. 0.87. What is the difference between the highest and the lowest Bank branche(per 100,000 adults) of Lithuania?
Your response must be concise. 4.5. 